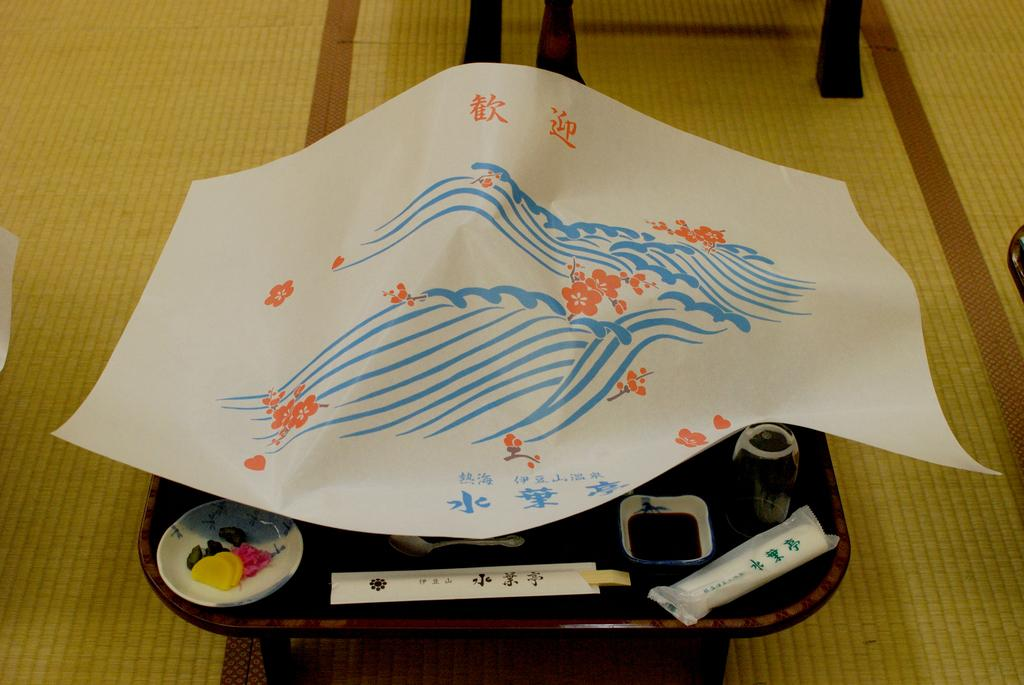What is the main piece of furniture in the image? There is a table in the image. What items can be seen on the table? A plate, a bowl, and a glass are visible on the table. How is the table covered? The table is covered with a paper. What is located at the bottom of the image? There is a floor mat at the bottom of the image. What type of game is being played on the table in the image? There is no game being played on the table in the image; it is covered with a paper and has a plate, bowl, and glass on it. 